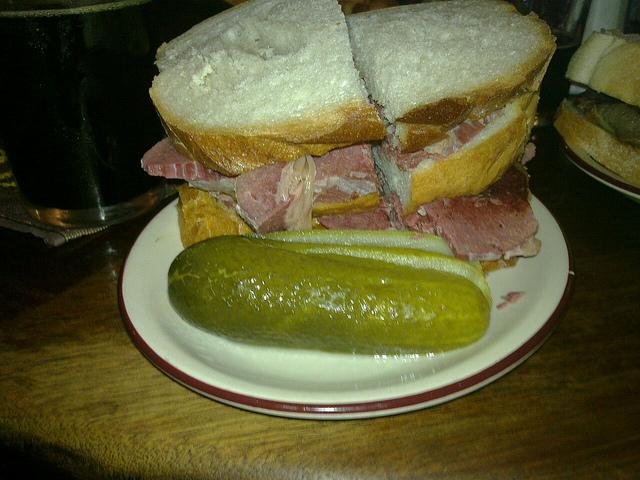What taste does the green food have? Please explain your reasoning. sour. The green food is a tart pickle. 